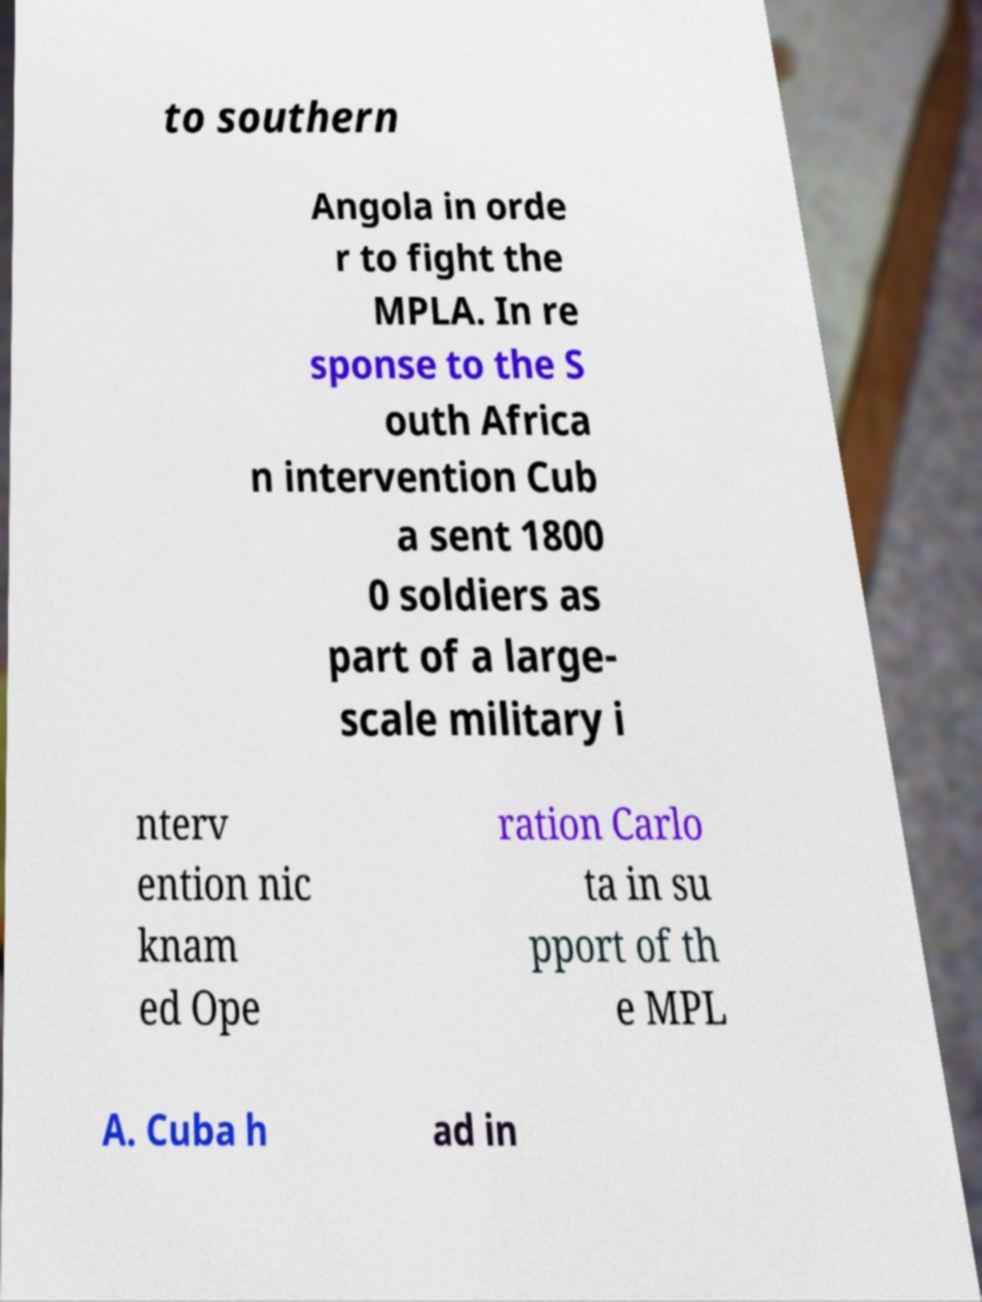For documentation purposes, I need the text within this image transcribed. Could you provide that? to southern Angola in orde r to fight the MPLA. In re sponse to the S outh Africa n intervention Cub a sent 1800 0 soldiers as part of a large- scale military i nterv ention nic knam ed Ope ration Carlo ta in su pport of th e MPL A. Cuba h ad in 